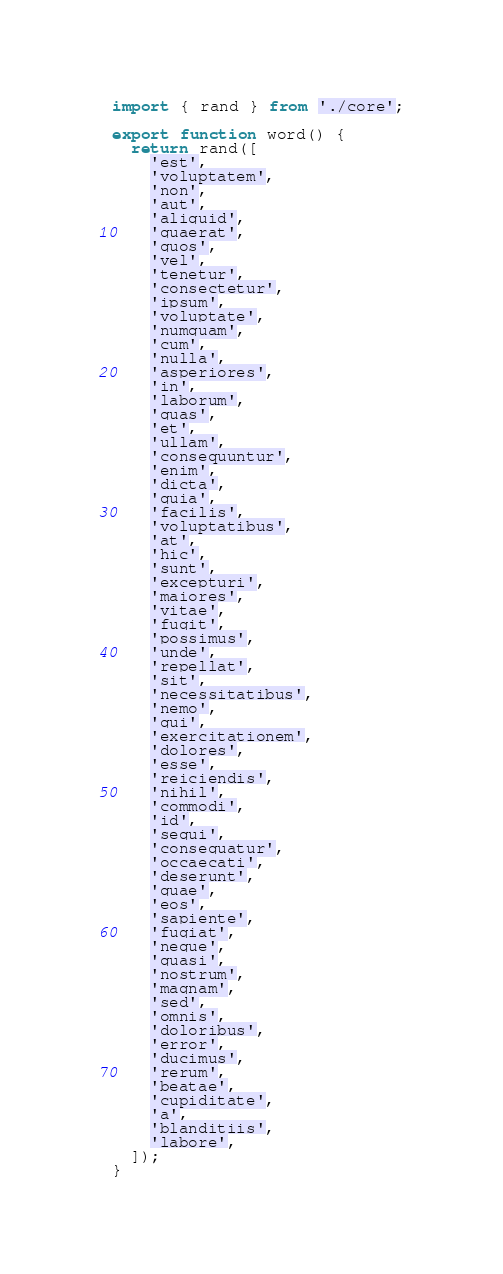Convert code to text. <code><loc_0><loc_0><loc_500><loc_500><_TypeScript_>import { rand } from './core';

export function word() {
  return rand([
    'est',
    'voluptatem',
    'non',
    'aut',
    'aliquid',
    'quaerat',
    'quos',
    'vel',
    'tenetur',
    'consectetur',
    'ipsum',
    'voluptate',
    'numquam',
    'cum',
    'nulla',
    'asperiores',
    'in',
    'laborum',
    'quas',
    'et',
    'ullam',
    'consequuntur',
    'enim',
    'dicta',
    'quia',
    'facilis',
    'voluptatibus',
    'at',
    'hic',
    'sunt',
    'excepturi',
    'maiores',
    'vitae',
    'fugit',
    'possimus',
    'unde',
    'repellat',
    'sit',
    'necessitatibus',
    'nemo',
    'qui',
    'exercitationem',
    'dolores',
    'esse',
    'reiciendis',
    'nihil',
    'commodi',
    'id',
    'sequi',
    'consequatur',
    'occaecati',
    'deserunt',
    'quae',
    'eos',
    'sapiente',
    'fugiat',
    'neque',
    'quasi',
    'nostrum',
    'magnam',
    'sed',
    'omnis',
    'doloribus',
    'error',
    'ducimus',
    'rerum',
    'beatae',
    'cupiditate',
    'a',
    'blanditiis',
    'labore',
  ]);
}
</code> 